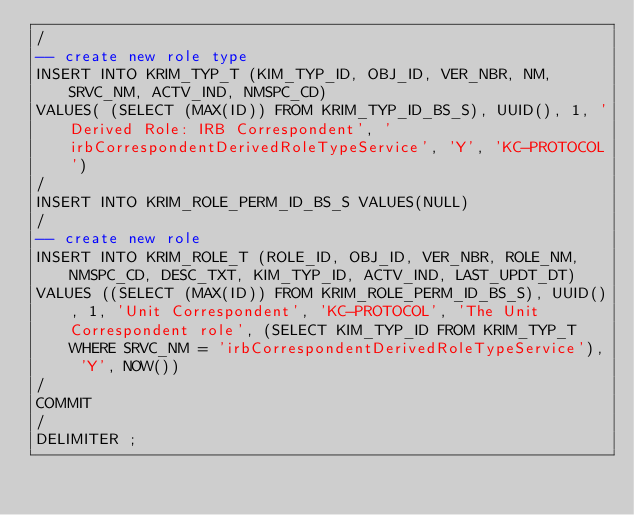Convert code to text. <code><loc_0><loc_0><loc_500><loc_500><_SQL_>/
-- create new role type
INSERT INTO KRIM_TYP_T (KIM_TYP_ID, OBJ_ID, VER_NBR, NM, SRVC_NM, ACTV_IND, NMSPC_CD)
VALUES( (SELECT (MAX(ID)) FROM KRIM_TYP_ID_BS_S), UUID(), 1, 'Derived Role: IRB Correspondent', 'irbCorrespondentDerivedRoleTypeService', 'Y', 'KC-PROTOCOL')
/
INSERT INTO KRIM_ROLE_PERM_ID_BS_S VALUES(NULL)
/
-- create new role
INSERT INTO KRIM_ROLE_T (ROLE_ID, OBJ_ID, VER_NBR, ROLE_NM, NMSPC_CD, DESC_TXT, KIM_TYP_ID, ACTV_IND, LAST_UPDT_DT)
VALUES ((SELECT (MAX(ID)) FROM KRIM_ROLE_PERM_ID_BS_S), UUID(), 1, 'Unit Correspondent', 'KC-PROTOCOL', 'The Unit Correspondent role', (SELECT KIM_TYP_ID FROM KRIM_TYP_T WHERE SRVC_NM = 'irbCorrespondentDerivedRoleTypeService'), 'Y', NOW())
/
COMMIT
/
DELIMITER ;
</code> 